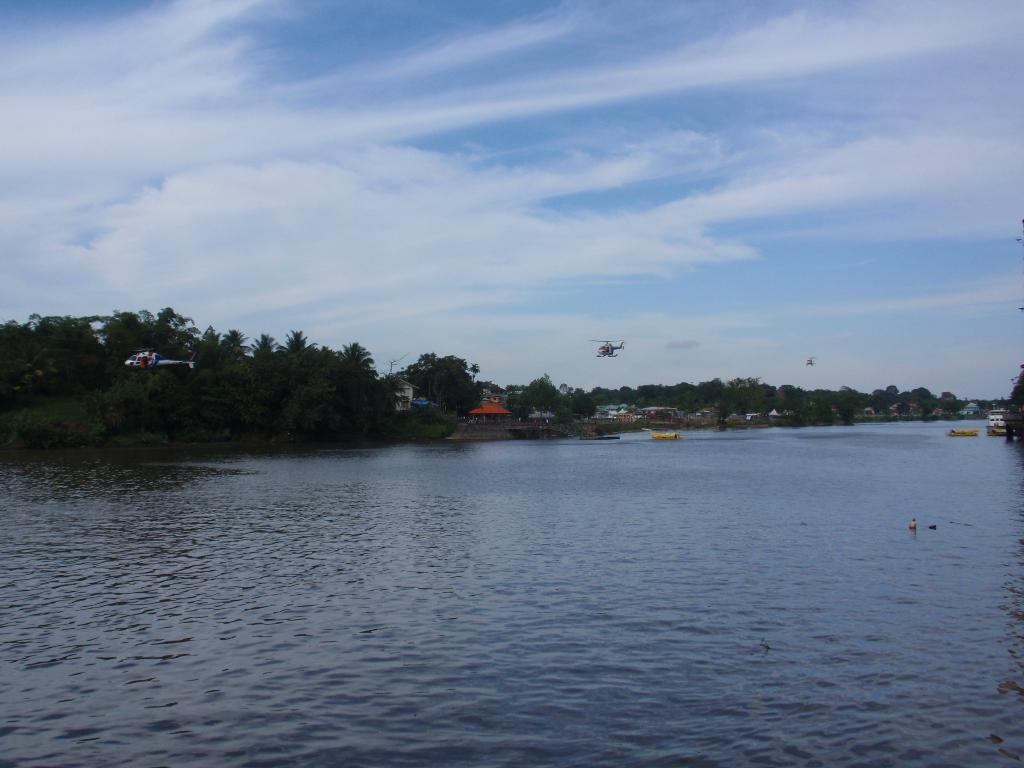What is located in the center of the image? There are trees, helicopters, houses, and boats in the center of the image. What type of vehicles can be seen in the image? Helicopters are visible in the image. What type of structures are present in the image? Houses are present in the image. What type of transportation can be seen in the image? Boats are visible in the image. What is visible in the sky at the top of the image? Clouds are present in the sky at the top of the image. What type of terrain is visible at the bottom of the image? Water is visible at the bottom of the image. What color jeans are the trees wearing in the image? Trees do not wear jeans, as they are living organisms and not human beings. How many times does the orange kick the ball in the image? There is no orange or ball present in the image, so this action cannot be observed. 